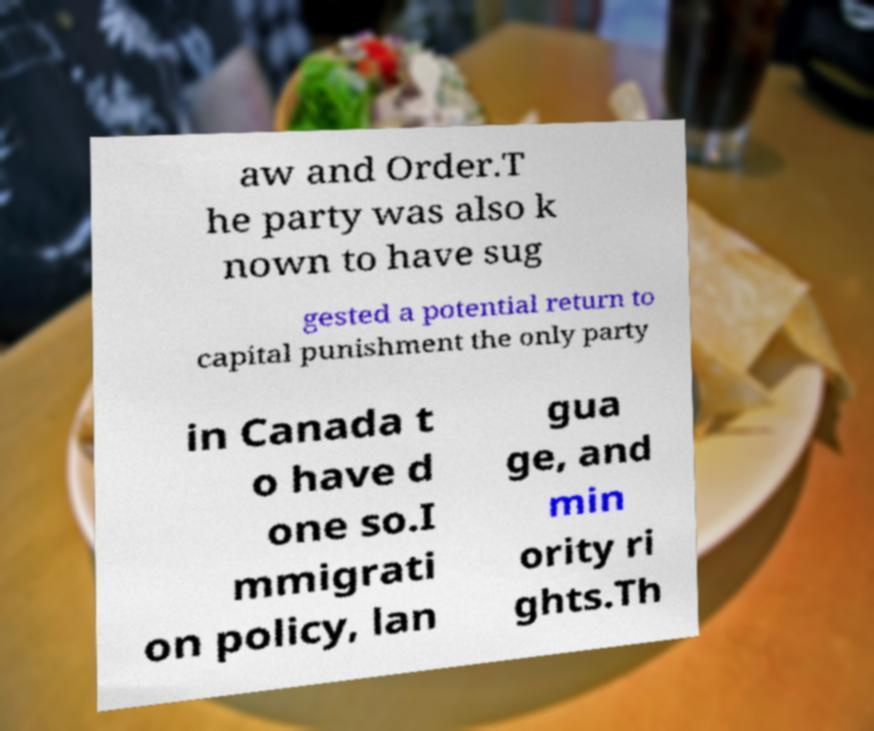Please read and relay the text visible in this image. What does it say? aw and Order.T he party was also k nown to have sug gested a potential return to capital punishment the only party in Canada t o have d one so.I mmigrati on policy, lan gua ge, and min ority ri ghts.Th 